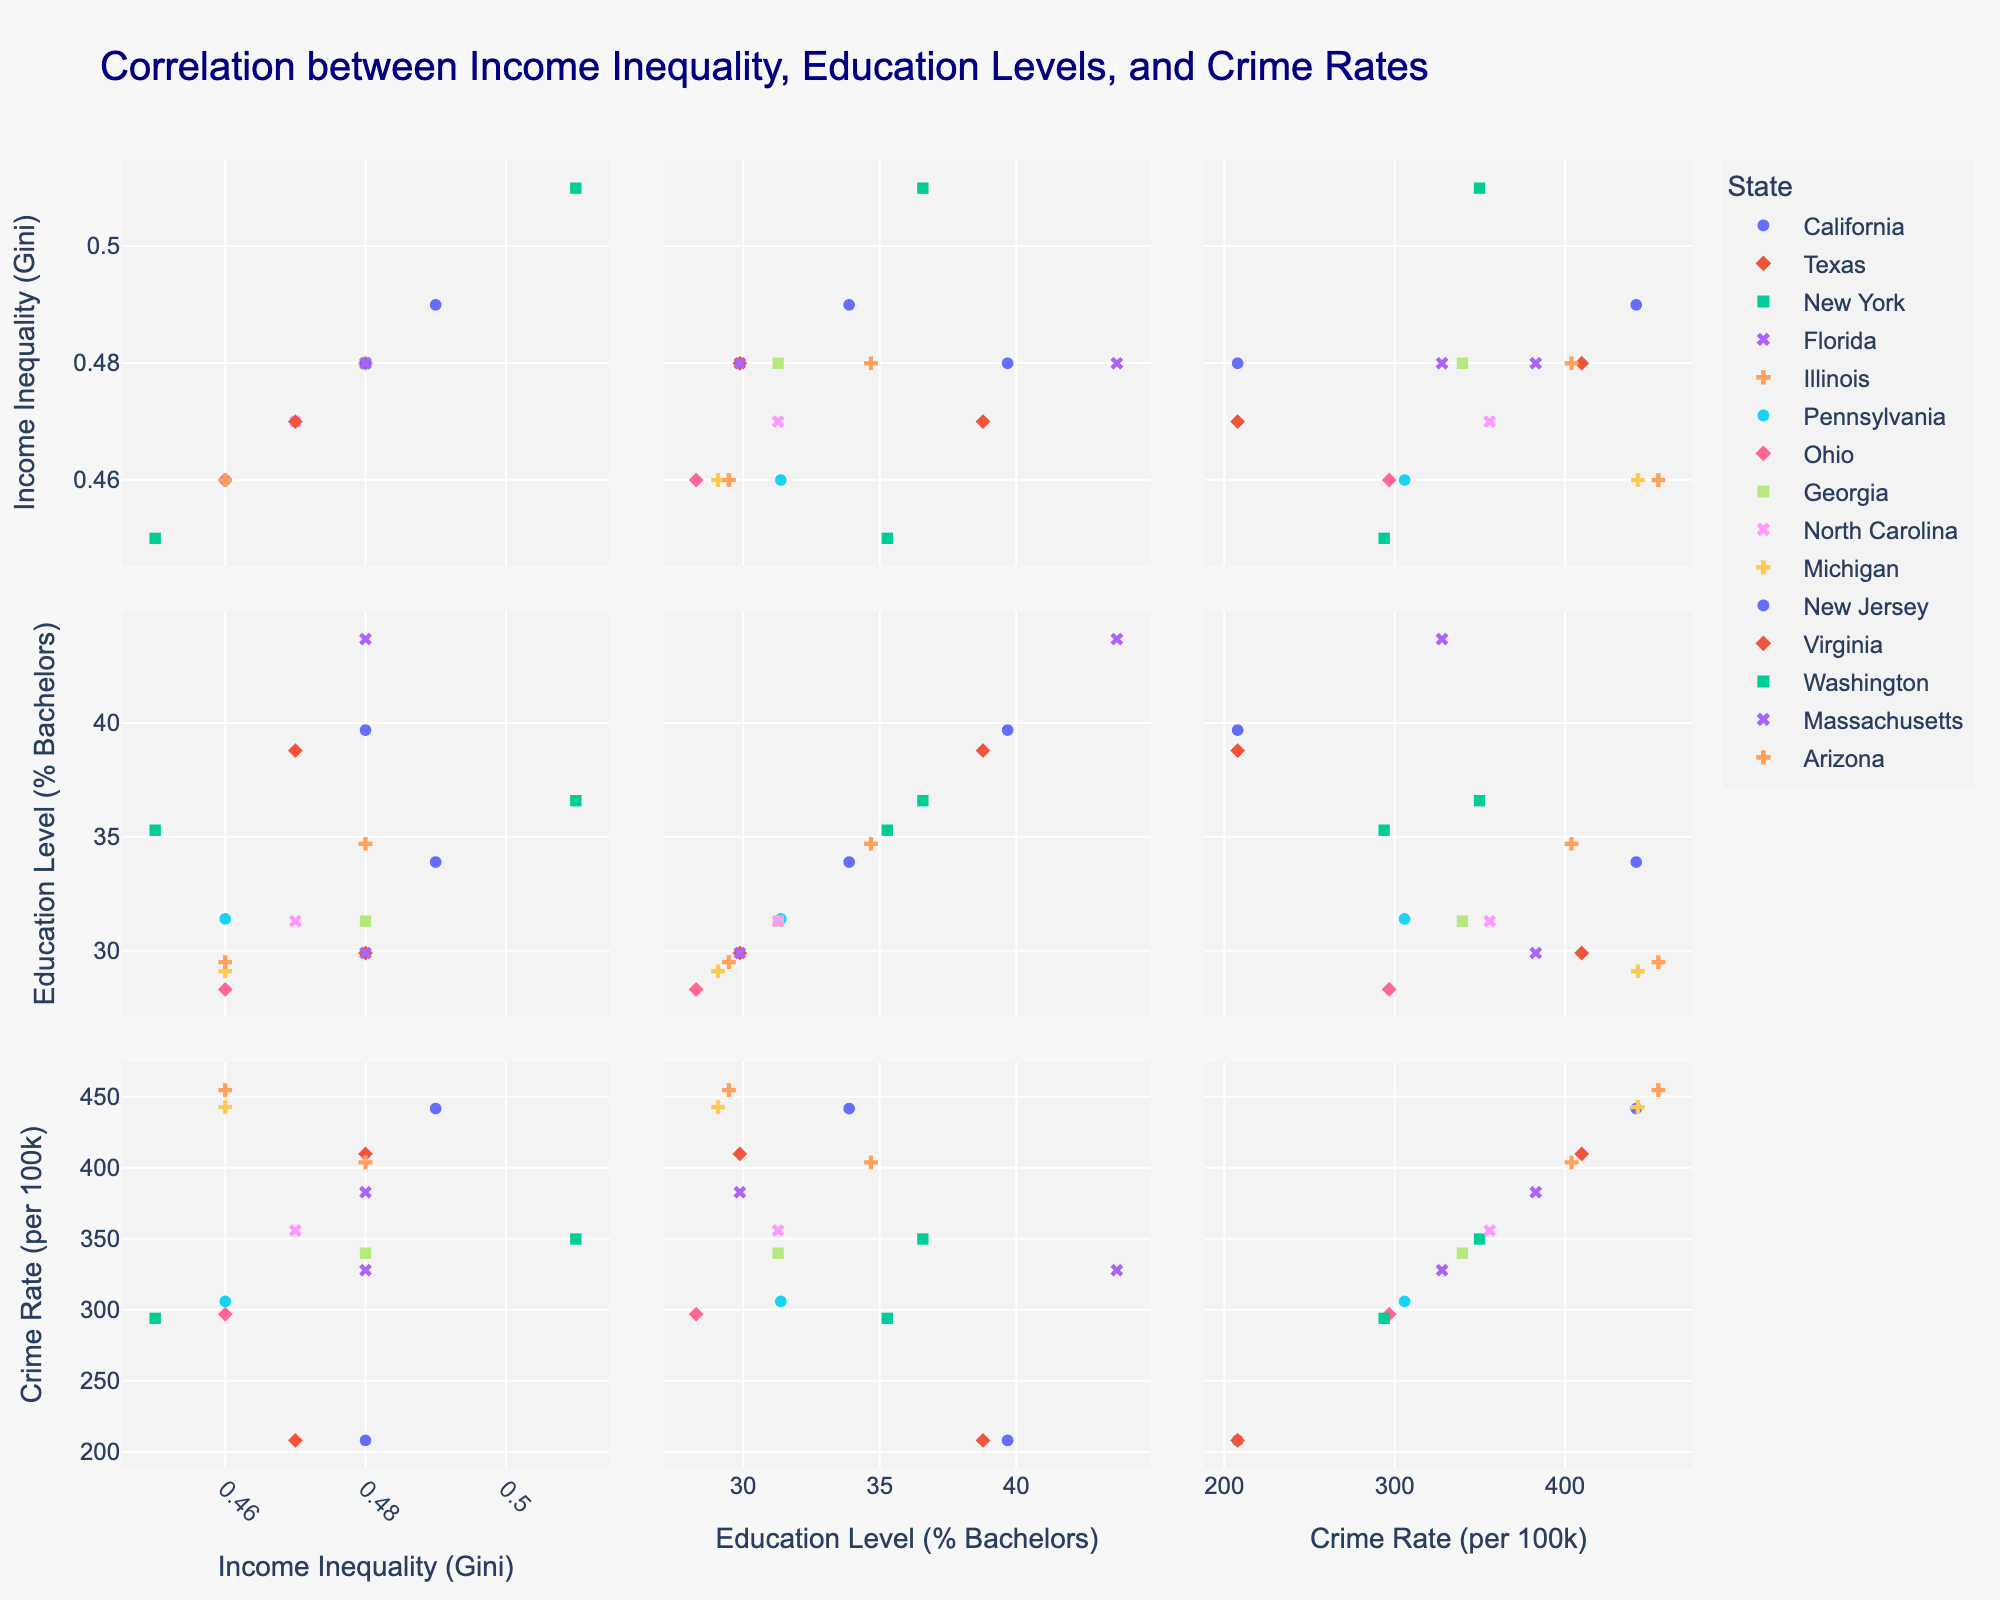what is the title of the plot? The plot's title is located at the top of the scatterplot matrix and it provides an overall description of what the figure represents.
Answer: Correlation between Income Inequality, Education Levels, and Crime Rates which state has the highest education level percentage of bachelor's degrees? To find this, look at the vertical axis labeled 'Education Level (% Bachelors).' Identify the highest data point and check which state it represents.
Answer: Massachusetts what is the relationship between income inequality and crime rate for New York? Locate New York data points and observe their positions on the income inequality (Gini) axis and the crime rate axis to understand the trend or correlation.
Answer: As income inequality increases, the crime rate appears high relatively comparing california and new jersey, which state has a lower crime rate per 100k? Locate the crime rate data points for both California and New Jersey on the crime rate axis and compare their positions.
Answer: New Jersey what is the education level percentage of bachelor's degrees in Texas? Find Texas on the scatter plot that shows education level (% Bachelors) and read the value directly.
Answer: 29.9% how many states have an income inequality Gini greater than 0.47? Count the number of states whose data points fall above 0.47 on the income inequality (Gini) axis.
Answer: 8 states are crime rates generally higher in states with lower education levels? Compare the distribution of data points in the matrix particularly focusing on the education level (%) vs. crime rate per 100k plot to identify any patterns.
Answer: Yes, generally which state has the lowest crime rate per 100k and what is that rate? Identify the lowest data point on the crime rate axis and check the corresponding state.
Answer: Virginia and New Jersey, 208 what correlation, if any, exists between education levels and income inequality? Look at the plot that compares education levels and income inequality and analyze the overall trend of the data points.
Answer: No clear correlation what is the general trend in states with high educational attainment in terms of crime rate? Examine the plot focusing on states with high educational attainment and observe the trend in their crime rates.
Answer: States with high educational attainment tend to have lower crime rates 